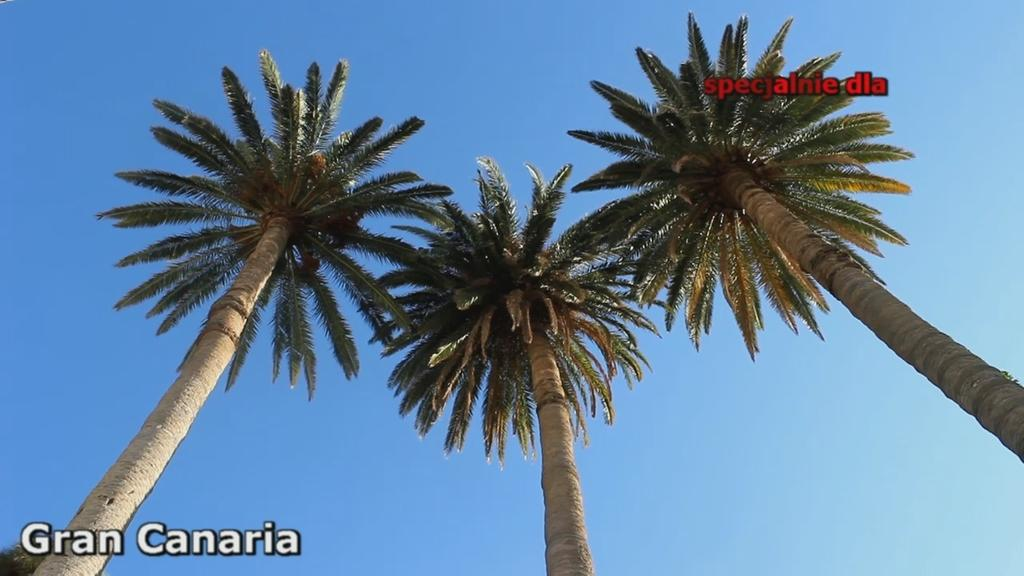How many coconut trees are visible in the image? There are three coconut trees in the image. Where are the coconut trees located in relation to the image? The coconut trees are in the front of the image. What can be seen above the coconut trees in the image? The sky is visible above the coconut trees. What type of tin can be seen hanging from the coconut trees in the image? There is no tin present in the image; it features three coconut trees with the sky visible above them. 